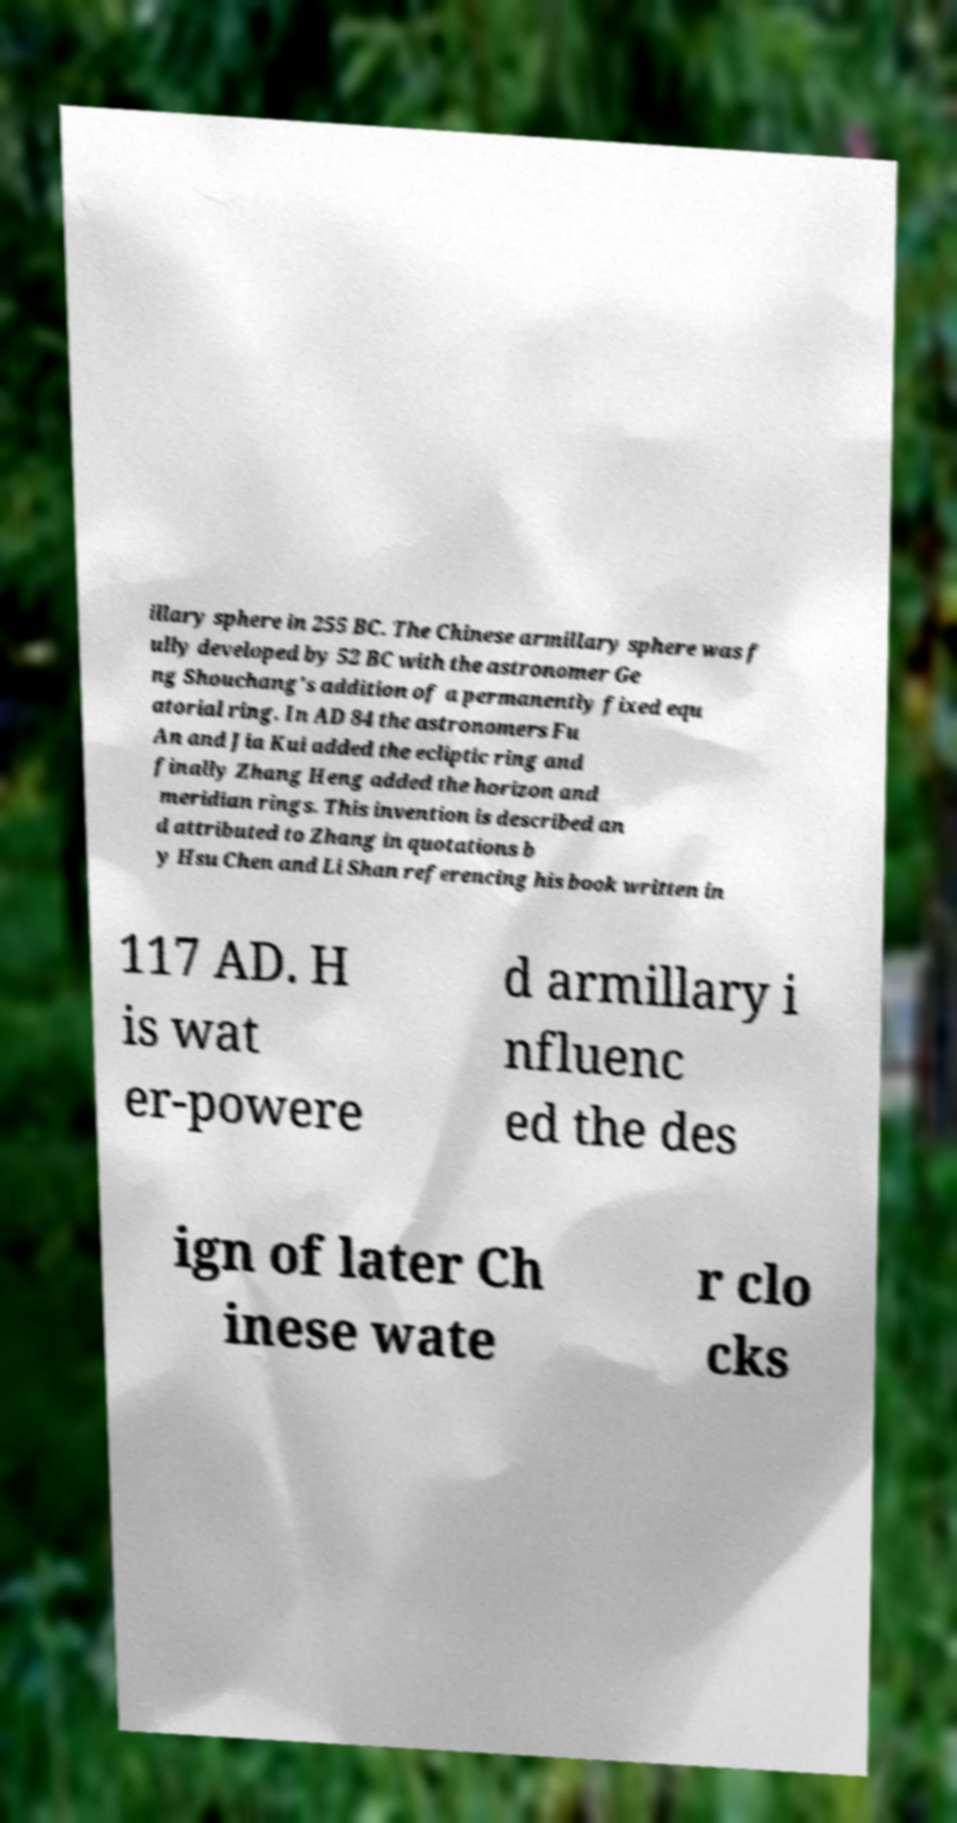For documentation purposes, I need the text within this image transcribed. Could you provide that? illary sphere in 255 BC. The Chinese armillary sphere was f ully developed by 52 BC with the astronomer Ge ng Shouchang's addition of a permanently fixed equ atorial ring. In AD 84 the astronomers Fu An and Jia Kui added the ecliptic ring and finally Zhang Heng added the horizon and meridian rings. This invention is described an d attributed to Zhang in quotations b y Hsu Chen and Li Shan referencing his book written in 117 AD. H is wat er-powere d armillary i nfluenc ed the des ign of later Ch inese wate r clo cks 